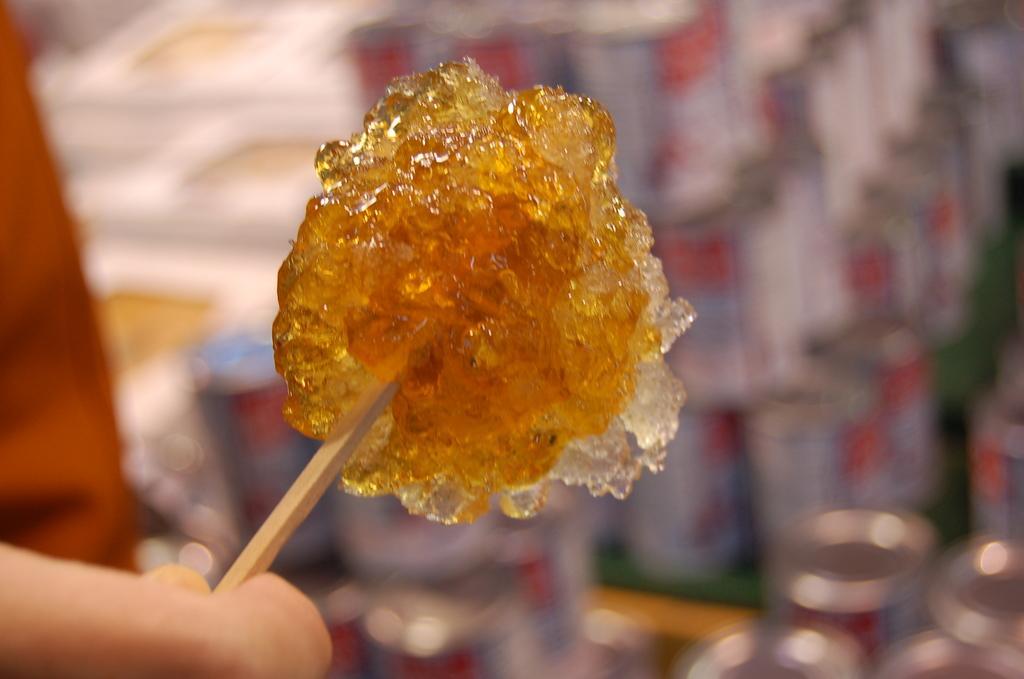In one or two sentences, can you explain what this image depicts? In the foreground of this image, there is a candy like an object to a stick which is holding by the hand of a person and the background image is blur. 